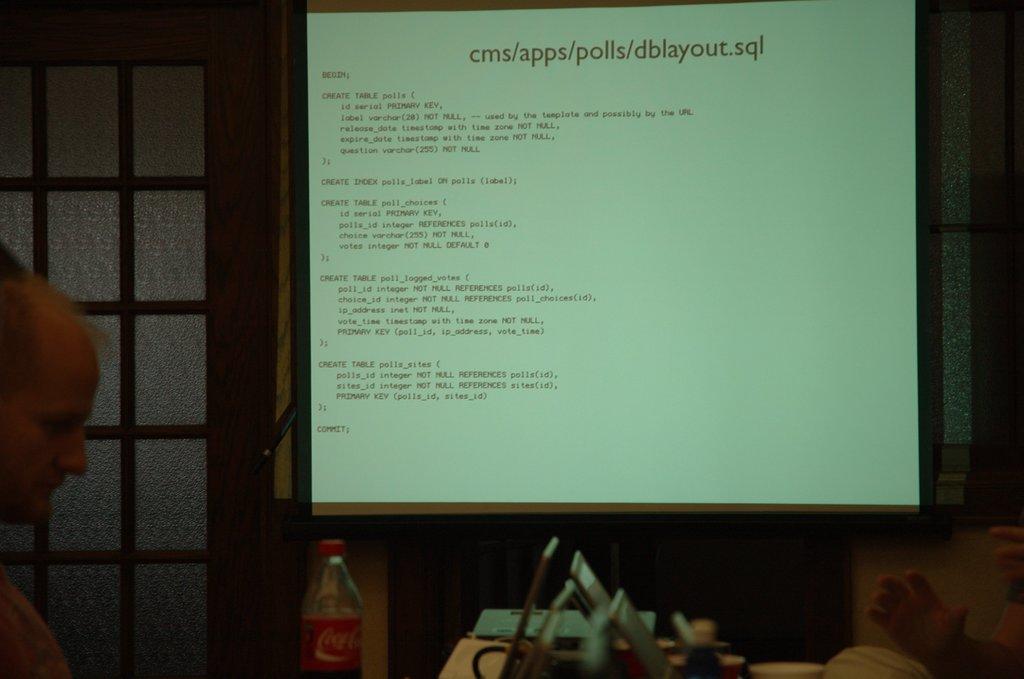What is the direct sub folder under cms?
Provide a short and direct response. Apps. What is the title at the top of the display?
Your answer should be compact. Cms/apps/polls/dblayout.sql. 